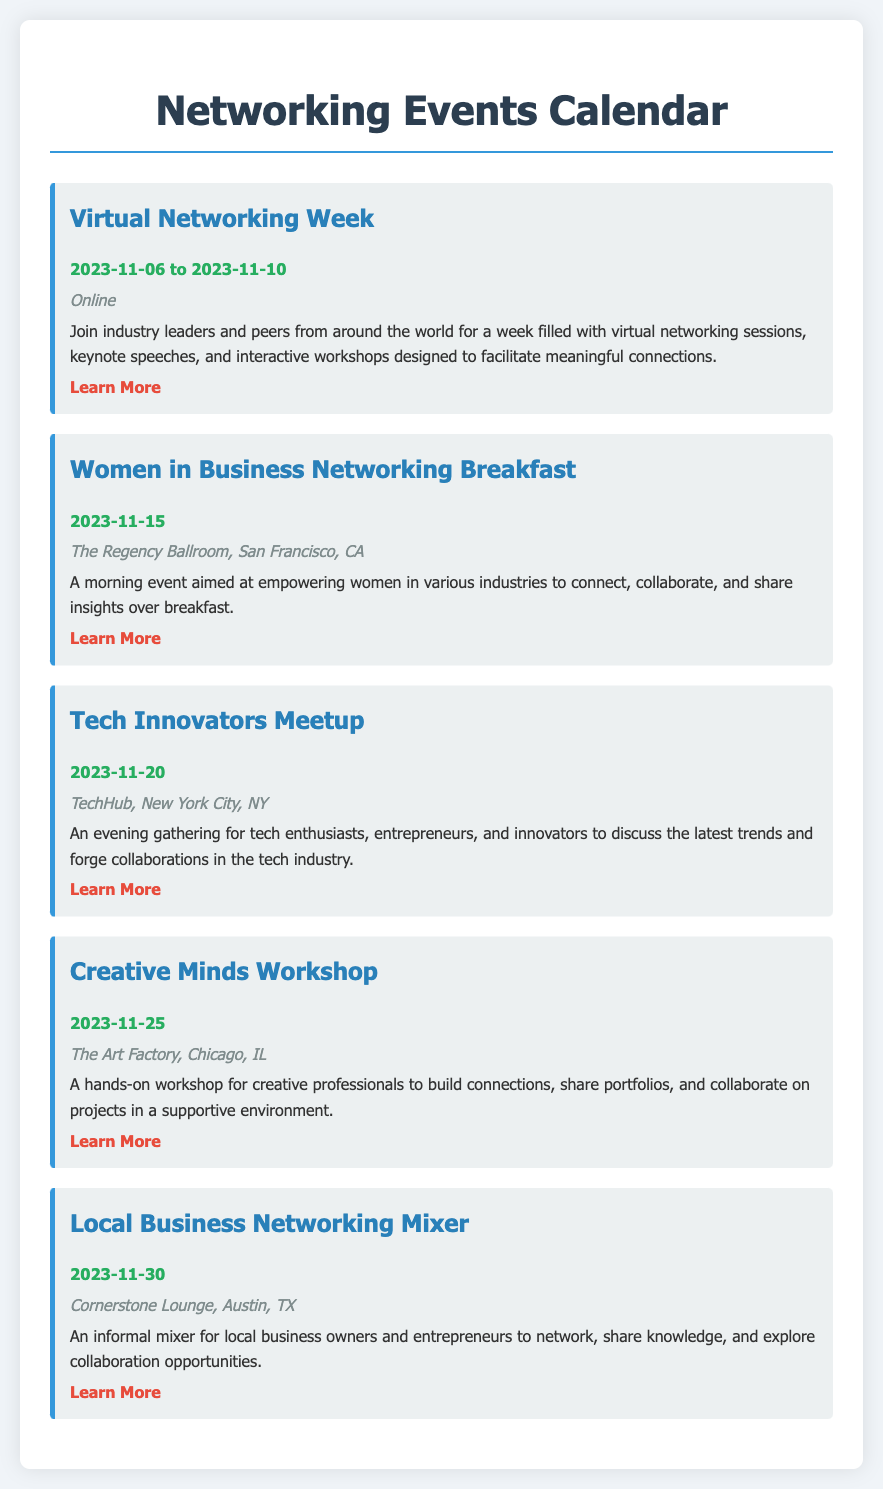What is the date range for the Virtual Networking Week? The event is scheduled from November 6 to November 10, 2023.
Answer: 2023-11-06 to 2023-11-10 Where is the Women in Business Networking Breakfast held? The event will take place at The Regency Ballroom, San Francisco, CA.
Answer: The Regency Ballroom, San Francisco, CA What type of event is the Tech Innovators Meetup? This is an evening gathering for tech enthusiasts, entrepreneurs, and innovators to discuss trends.
Answer: Evening gathering What is the focus of the Creative Minds Workshop? The workshop is aimed at creative professionals to build connections and collaborate on projects.
Answer: Build connections When is the Local Business Networking Mixer scheduled? It is set to occur on November 30, 2023.
Answer: 2023-11-30 How can participants learn more about the Virtual Networking Week? The event's details can be found at its official website.
Answer: https://www.virtualnetworkingweek.com What is the primary goal of the Women in Business Networking Breakfast? The goal is to empower women in various industries to connect and collaborate.
Answer: Empowering women In which city will the Creative Minds Workshop take place? The workshop is taking place in Chicago, IL.
Answer: Chicago, IL 